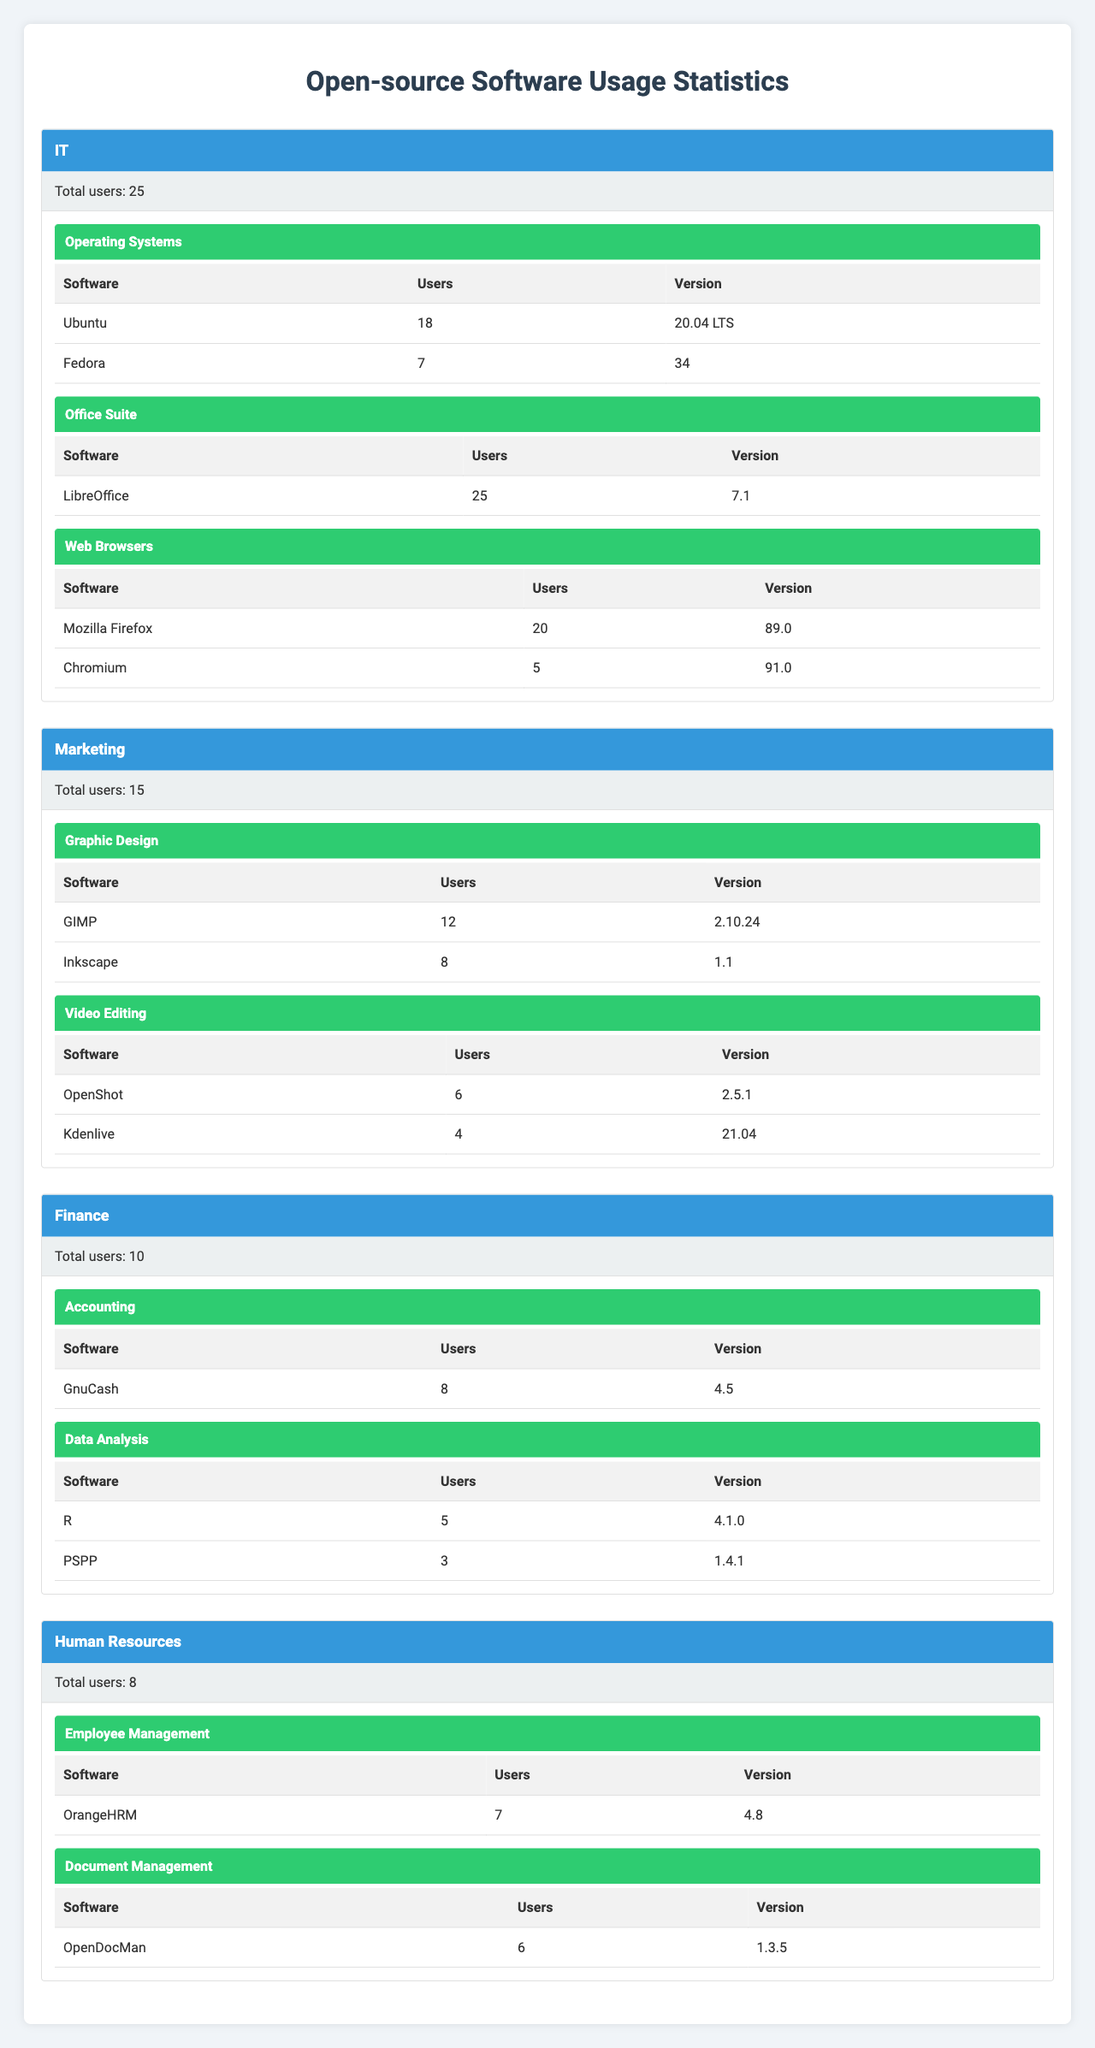What is the total number of users in the IT department? The IT department has a total of 25 users listed in the "Total users" row for that department.
Answer: 25 Which software in the Marketing department has the highest number of users? In the Marketing department, GIMP has the highest number of users with 12, as shown in its row under the "Graphic Design" category.
Answer: GIMP How many users in the Finance department use the software R? The software R has 5 users in the Finance department, as indicated in the respective row under the "Data Analysis" category.
Answer: 5 Is there any software in the Human Resources department that has more than 6 users? Yes, OrangeHRM has 7 users, which is more than 6, as shown in the "Employee Management" category.
Answer: Yes What is the total number of users across all departments for the software LibreOffice? LibreOffice has 25 users all in the IT department, and since it's only listed there, the total remains 25.
Answer: 25 Which department has the least number of total users? The department with the least number of total users is Human Resources, with only 8 users as specified in the "Total users" row for that department.
Answer: Human Resources How many users are there for all software under the "Operating Systems" category? For Operating Systems, there are 18 users for Ubuntu and 7 users for Fedora, so the total is 18 + 7 = 25 users.
Answer: 25 Assuming all software in the Finance department had an equal number of users, how many users should each software have to total to the current usage? Currently there are 10 users across 3 software (GnuCash, R, PSPP). Dividing 10 by 3 gives about 3.33. Thus, each software would need about 4 users (if rounded up) to total or exceed current usage.
Answer: Approximately 4 What is the combined total of users for Video Editing software in the Marketing department? In the Video Editing category, OpenShot has 6 users and Kdenlive has 4 users, so the combined total is 6 + 4 = 10 users.
Answer: 10 Which software category has the highest total number of users in the table? The Office Suite category in the IT department has the highest total with 25 users for LibreOffice, while all other software categories in the other departments have fewer combined users.
Answer: Office Suite 